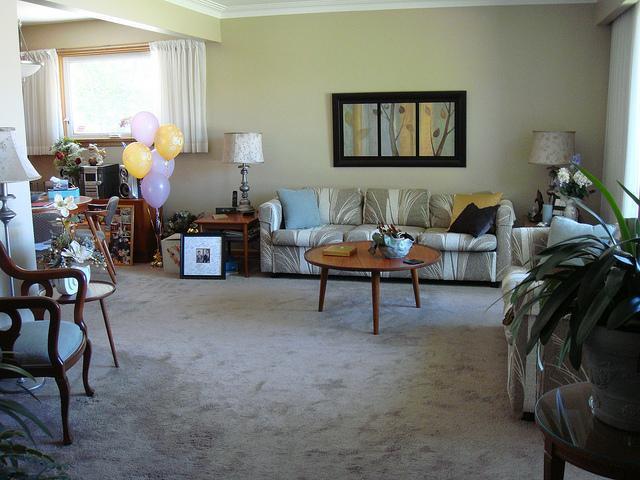How many couches are in the photo?
Give a very brief answer. 2. How many potted plants are in the picture?
Give a very brief answer. 2. 